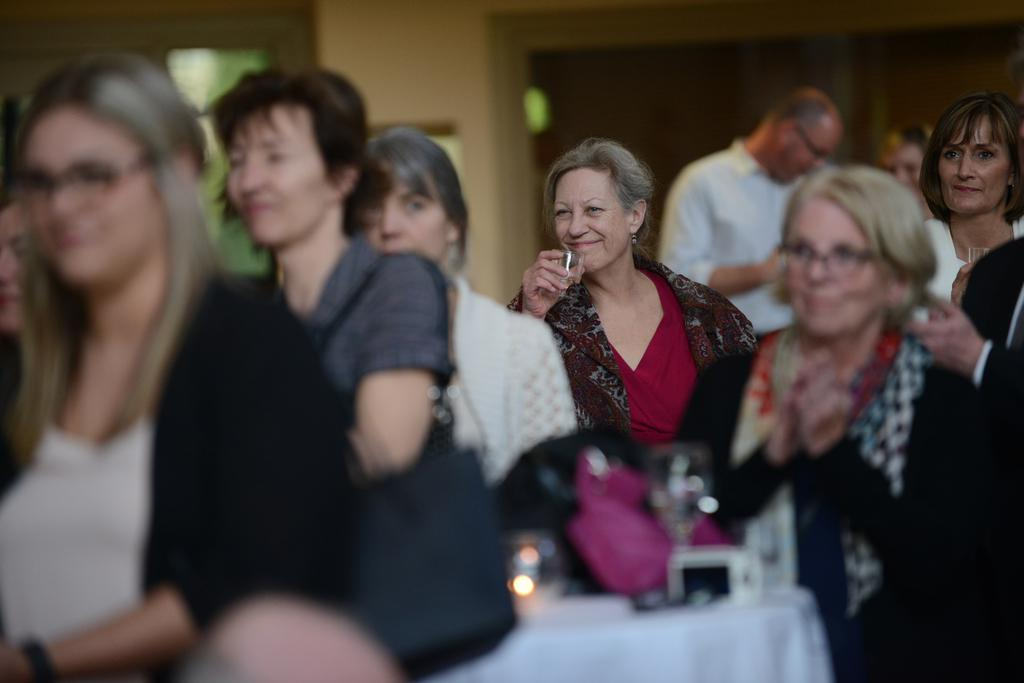What are the old women in the image doing? The old women in the image are sitting on chairs and clapping. What objects are some of the old women holding? Some of the old women are holding glasses. Can you describe the person in the background of the image? There is a man standing in the background of the image. Where does the scene appear to take place? The scene appears to be inside a conference hall. How many dogs can be seen playing on the floor in the image? There are no dogs present in the image; it features old women sitting on chairs, clapping, and holding glasses inside a conference hall. What type of bell is being rung by the old women in the image? There is no bell present in the image. 